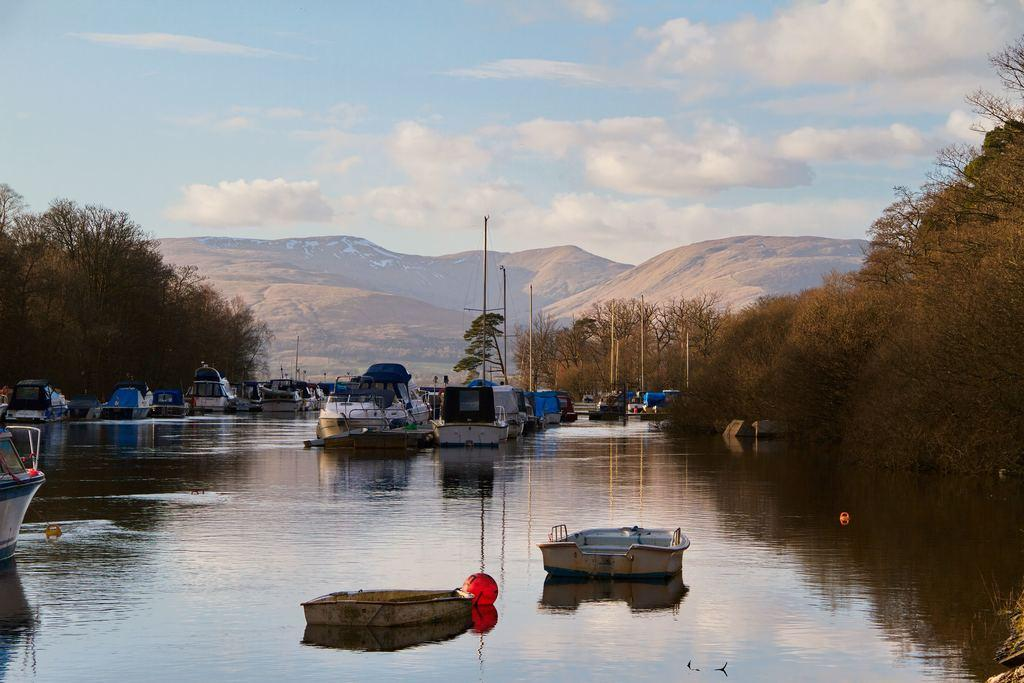What type of watercraft can be seen in the image? There are boats and a ship in the image. Where are the boats and ship located? The boats and ship are on the water in the image. What can be seen in the background of the image? Trees, mountains, and the sky are visible in the background of the image. What is the condition of the sky in the image? The sky is visible in the background of the image, and clouds are present. What grade does the visitor give to the hand in the image? There is no visitor or hand present in the image; it features boats, a ship, and a background with trees, mountains, and the sky. 